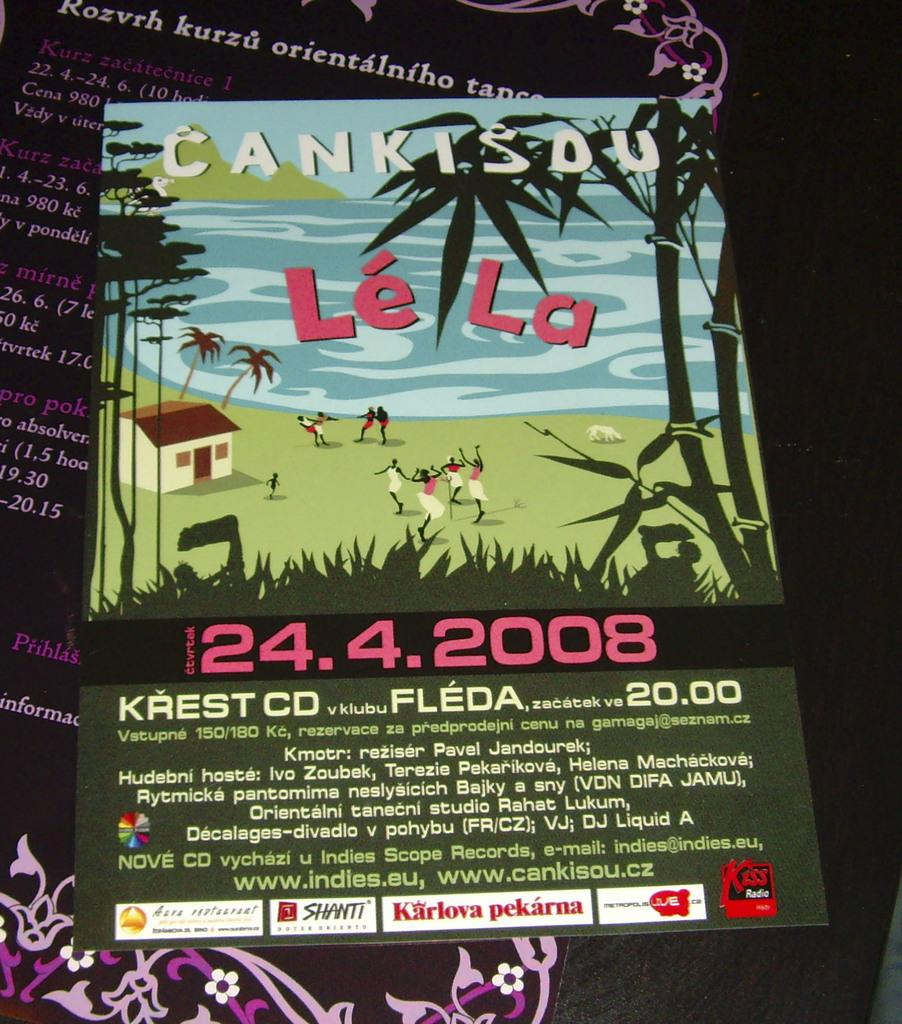<image>
Offer a succinct explanation of the picture presented. a flyer that says 'cankisou le la' on it 